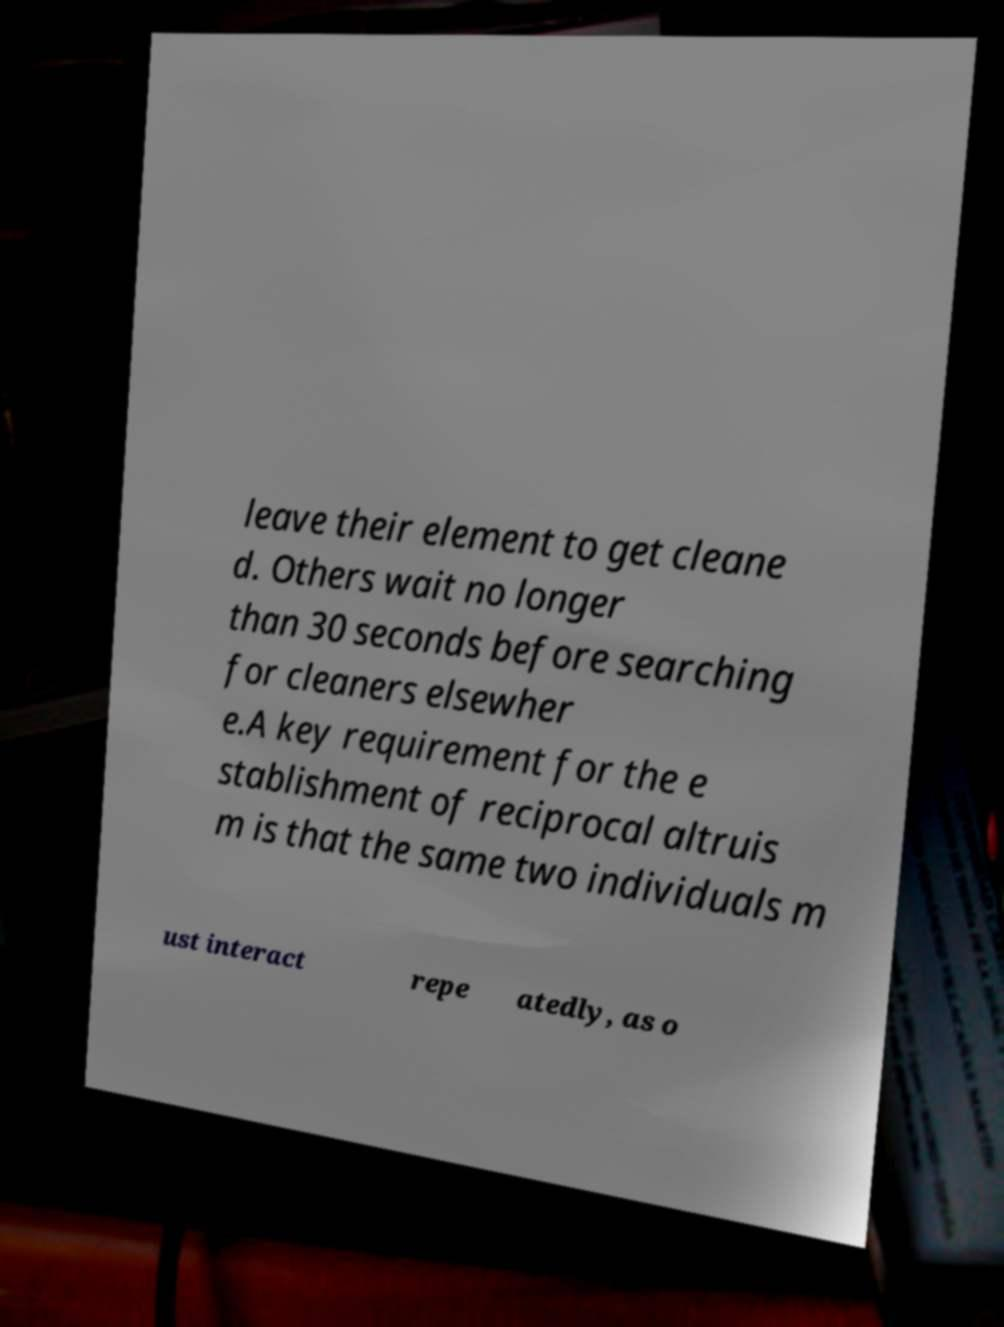Can you accurately transcribe the text from the provided image for me? leave their element to get cleane d. Others wait no longer than 30 seconds before searching for cleaners elsewher e.A key requirement for the e stablishment of reciprocal altruis m is that the same two individuals m ust interact repe atedly, as o 